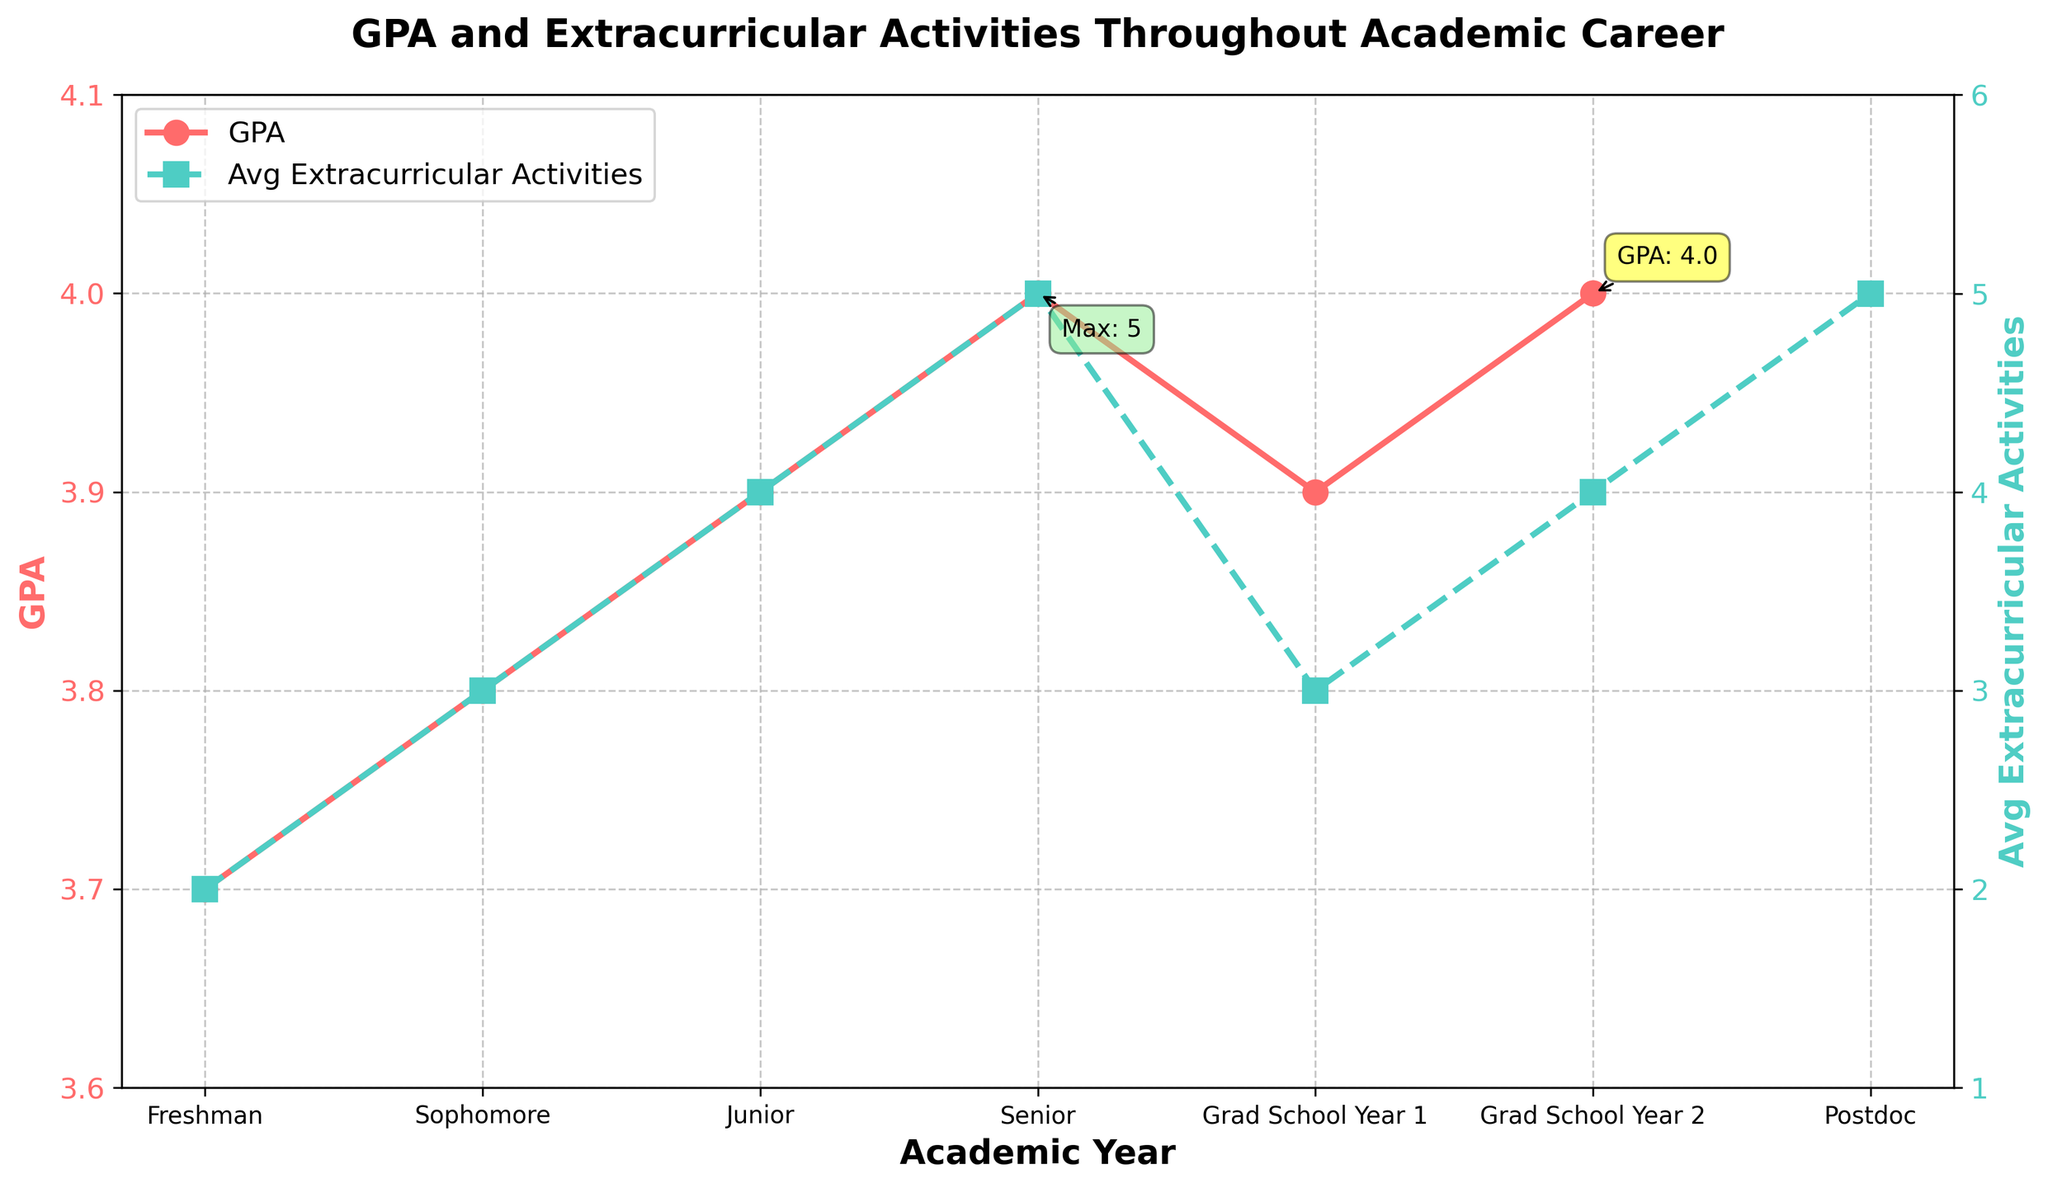What is the trend in GPA from Freshman to Senior year? The line representing GPA on the left y-axis shows an upward trend from Freshman (3.7) to Senior year (4.0).
Answer: Upward What is the maximum number of extracurricular activities recorded in the figure, and in which year does it occur? The highest point on the Avg Extracurricular Activities line (green, right y-axis) is 5, occurring in the Postdoc year.
Answer: Postdoc, 5 How does the GPA change from the last year of undergrad (Senior) to the first year of grad school (Grad School Year 1)? The GPA decreases from 4.0 in the Senior year to 3.9 in Grad School Year 1, as shown by a drop in the red line.
Answer: Decreases Compare the number of extracurricular activities between Sophomore and Grad School Year 2. Which year had more, and by how many? Sophomore year had 3 activities, whereas Grad School Year 2 had 4 activities. The difference is 1.
Answer: Grad School Year 2, 1 By how much does the GPA increase from Freshman year to Senior year? The GPA increases from 3.7 in Freshman year to 4.0 in Senior year. The increase is calculated as 4.0 - 3.7 = 0.3.
Answer: 0.3 What is the average number of extracurricular activities throughout the academic career (excluding Postdoc)? Summing up the activities for Freshman to Grad School Year 2 (2, 3, 4, 5, 3, 4) gives a total of 21. Dividing by the 6 years gives an average of 21/6 = 3.5.
Answer: 3.5 Which year shows the greatest change in the number of extracurricular activities compared to the previous year, and what is that change? The change from Sophomore to Junior year is the greatest, increasing by 1 (from 3 to 4).
Answer: Junior, 1 In which years is the GPA exactly 4.0? According to the red GPA line, GPA is 4.0 in the Senior year and Grad School Year 2.
Answer: Senior, Grad School Year 2 What is the overall trend in extracurricular activity participation from Freshman year to Postdoc? The green line representing extracurricular activities shows an upward trend, increasing from 2 in Freshman year to 5 in Postdoc.
Answer: Upward 